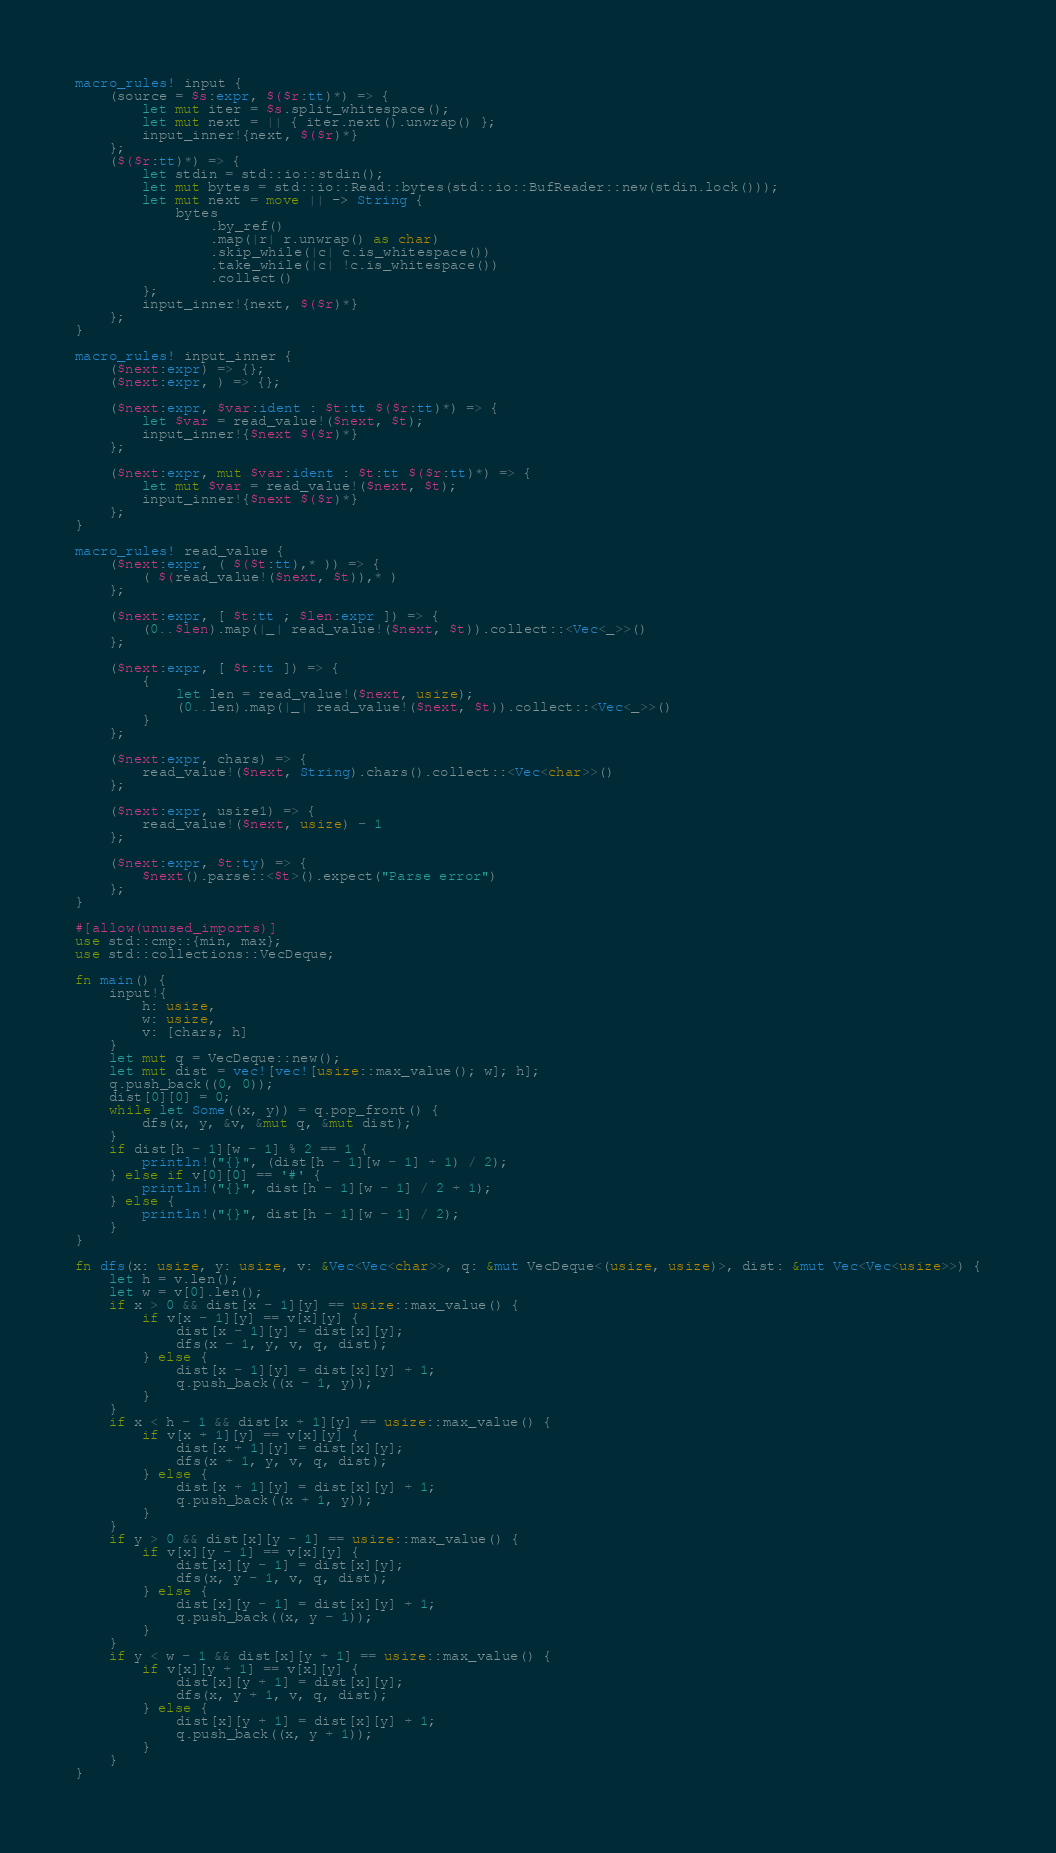Convert code to text. <code><loc_0><loc_0><loc_500><loc_500><_Rust_>macro_rules! input {
    (source = $s:expr, $($r:tt)*) => {
        let mut iter = $s.split_whitespace();
        let mut next = || { iter.next().unwrap() };
        input_inner!{next, $($r)*}
    };
    ($($r:tt)*) => {
        let stdin = std::io::stdin();
        let mut bytes = std::io::Read::bytes(std::io::BufReader::new(stdin.lock()));
        let mut next = move || -> String {
            bytes
                .by_ref()
                .map(|r| r.unwrap() as char)
                .skip_while(|c| c.is_whitespace())
                .take_while(|c| !c.is_whitespace())
                .collect()
        };
        input_inner!{next, $($r)*}
    };
}

macro_rules! input_inner {
    ($next:expr) => {};
    ($next:expr, ) => {};

    ($next:expr, $var:ident : $t:tt $($r:tt)*) => {
        let $var = read_value!($next, $t);
        input_inner!{$next $($r)*}
    };

    ($next:expr, mut $var:ident : $t:tt $($r:tt)*) => {
        let mut $var = read_value!($next, $t);
        input_inner!{$next $($r)*}
    };
}

macro_rules! read_value {
    ($next:expr, ( $($t:tt),* )) => {
        ( $(read_value!($next, $t)),* )
    };

    ($next:expr, [ $t:tt ; $len:expr ]) => {
        (0..$len).map(|_| read_value!($next, $t)).collect::<Vec<_>>()
    };

    ($next:expr, [ $t:tt ]) => {
        {
            let len = read_value!($next, usize);
            (0..len).map(|_| read_value!($next, $t)).collect::<Vec<_>>()
        }
    };

    ($next:expr, chars) => {
        read_value!($next, String).chars().collect::<Vec<char>>()
    };

    ($next:expr, usize1) => {
        read_value!($next, usize) - 1
    };

    ($next:expr, $t:ty) => {
        $next().parse::<$t>().expect("Parse error")
    };
}

#[allow(unused_imports)]
use std::cmp::{min, max};
use std::collections::VecDeque;

fn main() {
    input!{
        h: usize,
        w: usize,
        v: [chars; h]
    }
    let mut q = VecDeque::new();
    let mut dist = vec![vec![usize::max_value(); w]; h];
    q.push_back((0, 0));
    dist[0][0] = 0;
    while let Some((x, y)) = q.pop_front() {
        dfs(x, y, &v, &mut q, &mut dist);
    }
    if dist[h - 1][w - 1] % 2 == 1 {
        println!("{}", (dist[h - 1][w - 1] + 1) / 2);
    } else if v[0][0] == '#' {
        println!("{}", dist[h - 1][w - 1] / 2 + 1);
    } else {
        println!("{}", dist[h - 1][w - 1] / 2);
    }
}

fn dfs(x: usize, y: usize, v: &Vec<Vec<char>>, q: &mut VecDeque<(usize, usize)>, dist: &mut Vec<Vec<usize>>) {
    let h = v.len();
    let w = v[0].len();
    if x > 0 && dist[x - 1][y] == usize::max_value() {
        if v[x - 1][y] == v[x][y] {
            dist[x - 1][y] = dist[x][y];
            dfs(x - 1, y, v, q, dist);
        } else {
            dist[x - 1][y] = dist[x][y] + 1;
            q.push_back((x - 1, y));
        }
    }
    if x < h - 1 && dist[x + 1][y] == usize::max_value() {
        if v[x + 1][y] == v[x][y] {
            dist[x + 1][y] = dist[x][y];
            dfs(x + 1, y, v, q, dist);
        } else {
            dist[x + 1][y] = dist[x][y] + 1;
            q.push_back((x + 1, y));
        }
    }
    if y > 0 && dist[x][y - 1] == usize::max_value() {
        if v[x][y - 1] == v[x][y] {
            dist[x][y - 1] = dist[x][y];
            dfs(x, y - 1, v, q, dist);
        } else {
            dist[x][y - 1] = dist[x][y] + 1;
            q.push_back((x, y - 1));
        }
    }
    if y < w - 1 && dist[x][y + 1] == usize::max_value() {
        if v[x][y + 1] == v[x][y] {
            dist[x][y + 1] = dist[x][y];
            dfs(x, y + 1, v, q, dist);
        } else {
            dist[x][y + 1] = dist[x][y] + 1;
            q.push_back((x, y + 1));
        }
    }
}
</code> 